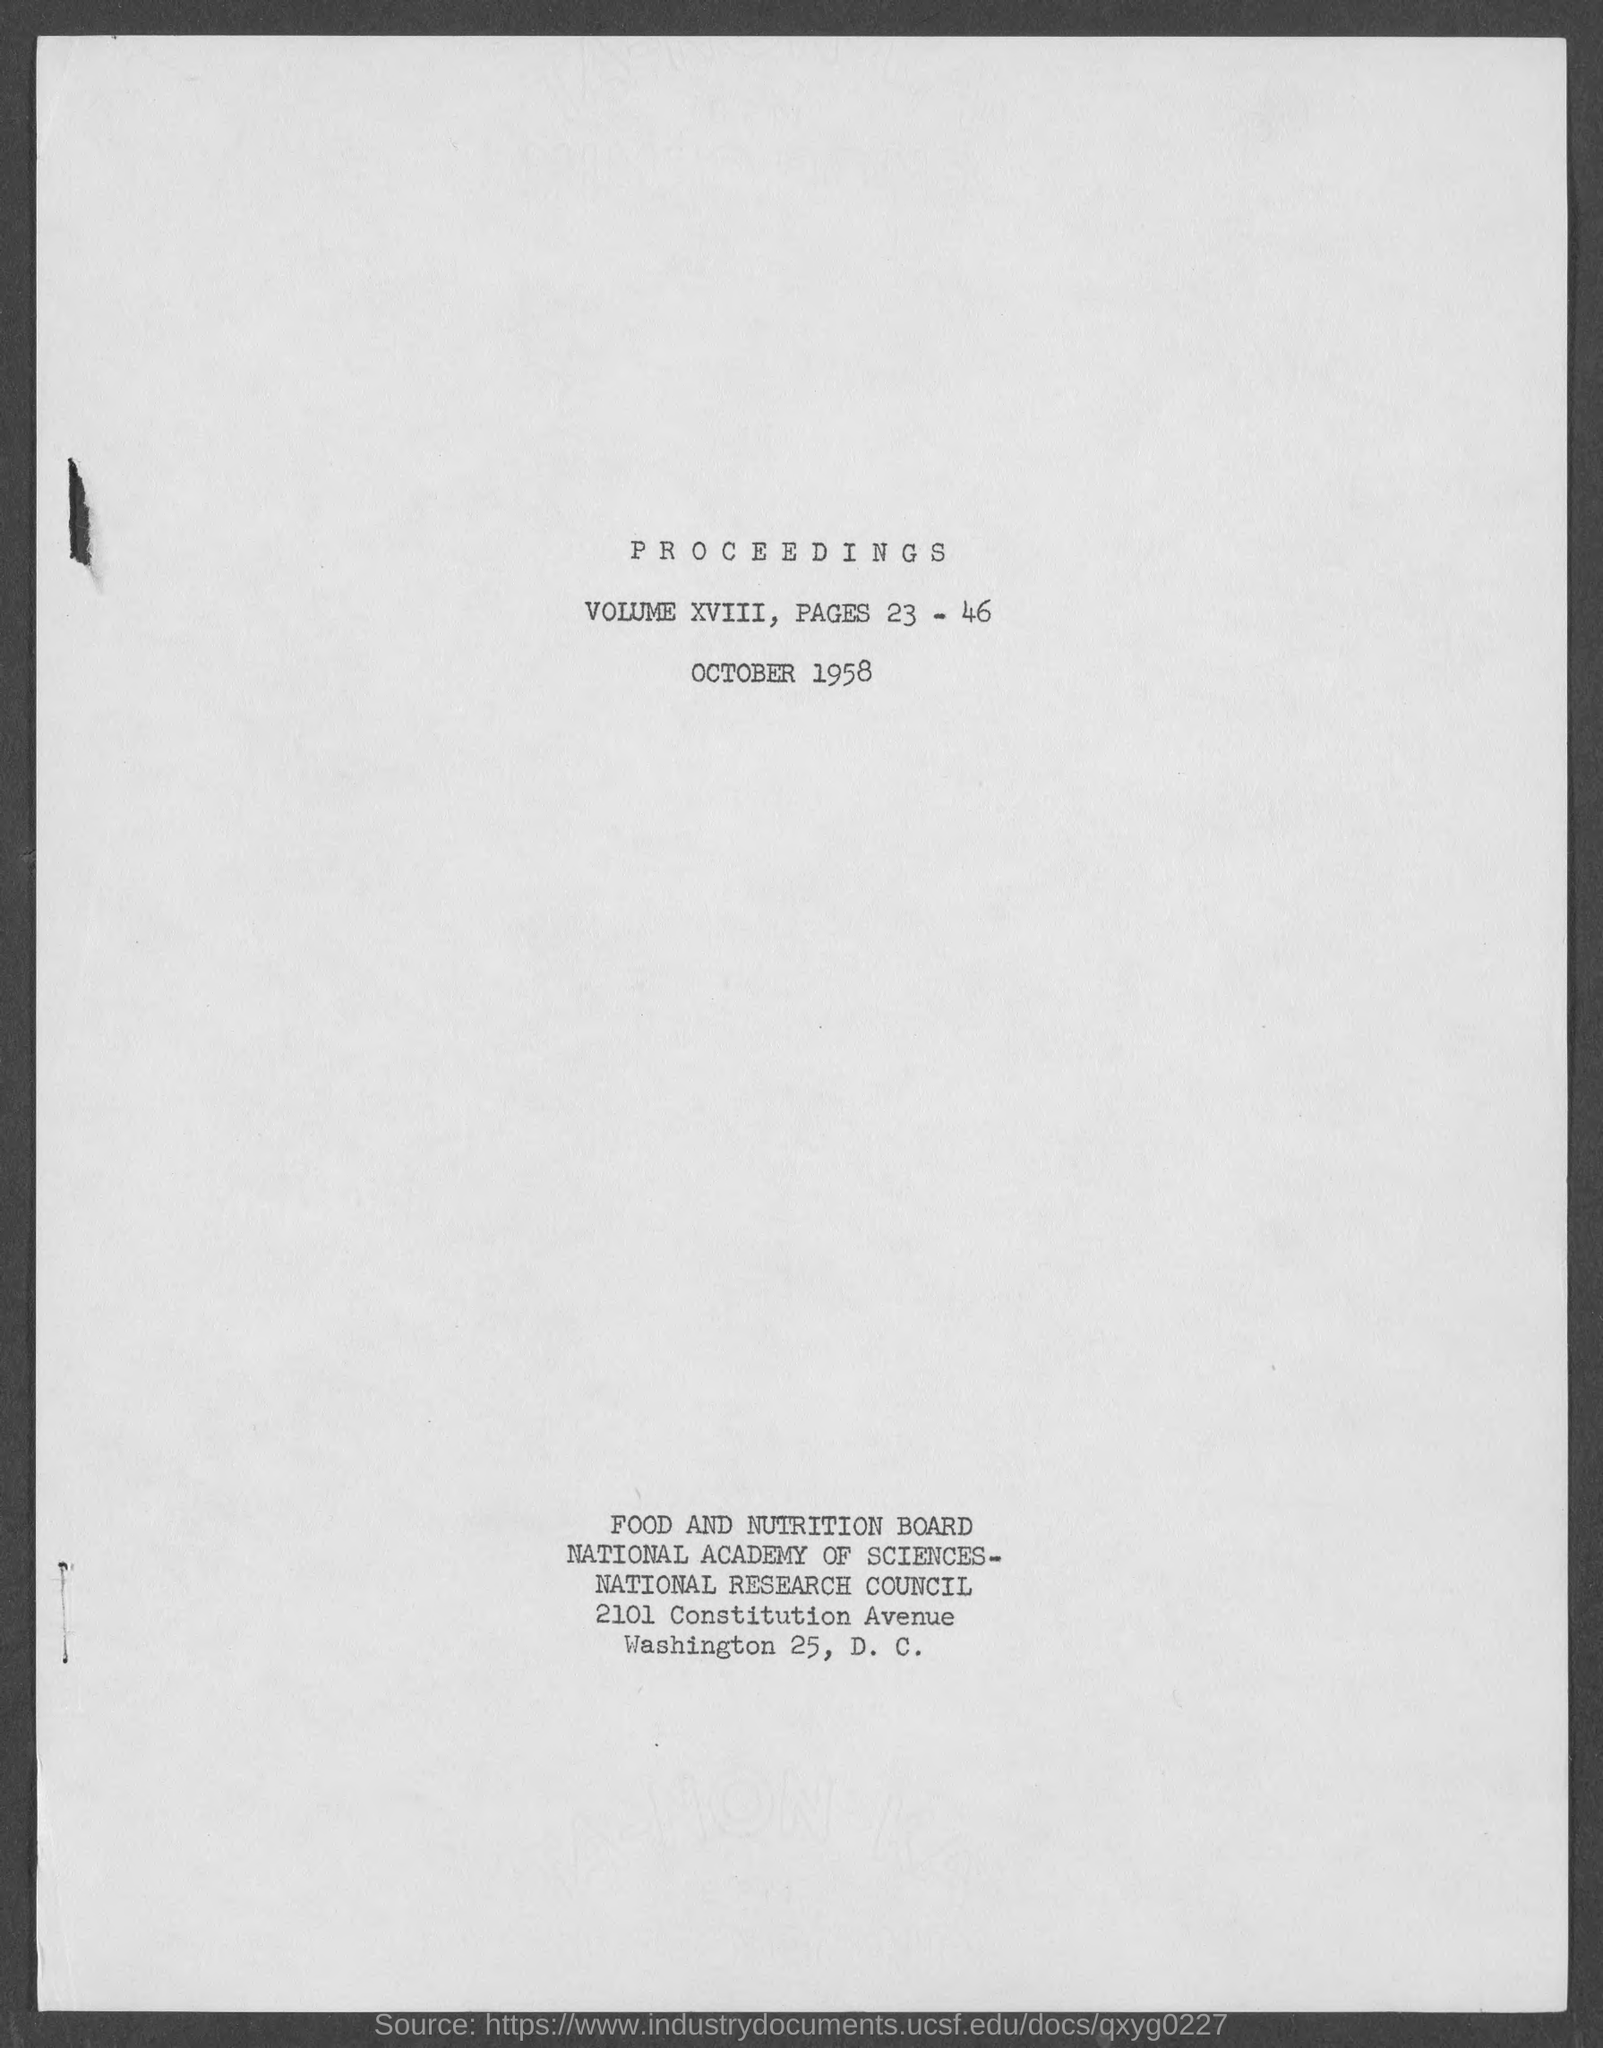What is the volume no. given for the Proceedings?
Offer a terse response. VOLUME XVIII. What is the page number issued for the Proceedings?
Offer a very short reply. 23 - 46. What is the date mentioned for the Proceedings?
Provide a short and direct response. OCTOBER 1958. 